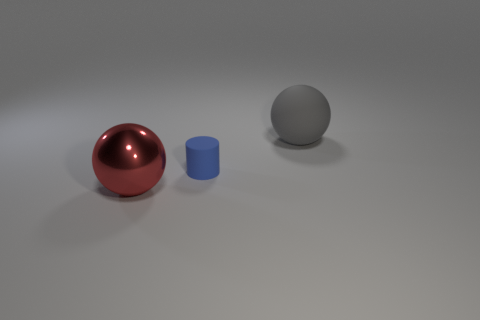Are there any large objects made of the same material as the red sphere?
Your response must be concise. No. What is the shape of the small blue matte thing?
Make the answer very short. Cylinder. Do the gray sphere and the red metallic thing have the same size?
Offer a very short reply. Yes. How many other objects are the same shape as the metallic object?
Give a very brief answer. 1. What is the shape of the gray object to the right of the large shiny sphere?
Provide a succinct answer. Sphere. There is a large object that is on the left side of the big matte sphere; is its shape the same as the big thing to the right of the big red thing?
Your response must be concise. Yes. Are there an equal number of red metal balls to the right of the large red shiny sphere and big shiny spheres?
Your answer should be compact. No. Are there any other things that have the same size as the rubber cylinder?
Ensure brevity in your answer.  No. What is the material of the other big object that is the same shape as the large gray matte thing?
Give a very brief answer. Metal. There is a tiny matte object that is behind the big object that is in front of the gray rubber thing; what shape is it?
Keep it short and to the point. Cylinder. 